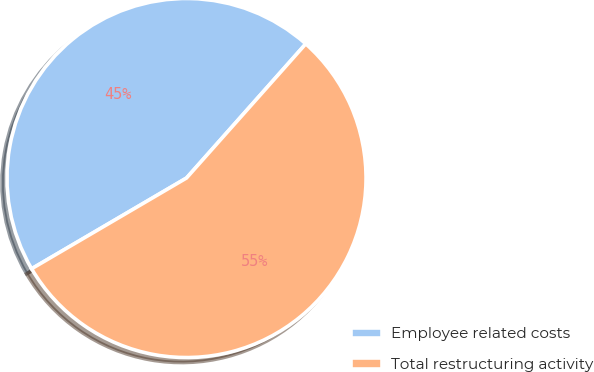Convert chart to OTSL. <chart><loc_0><loc_0><loc_500><loc_500><pie_chart><fcel>Employee related costs<fcel>Total restructuring activity<nl><fcel>45.0%<fcel>55.0%<nl></chart> 